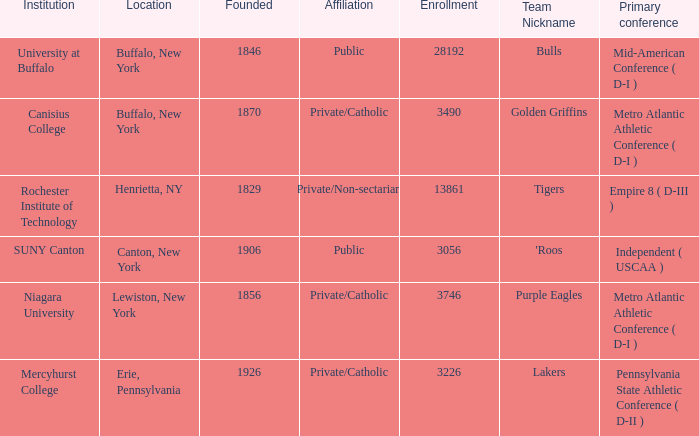What kind of school is Canton, New York? Public. 